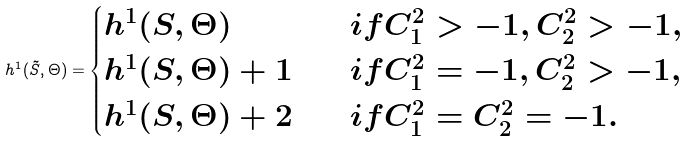<formula> <loc_0><loc_0><loc_500><loc_500>h ^ { 1 } ( \tilde { S } , \Theta ) = \begin{cases} h ^ { 1 } ( S , \Theta ) & \quad i f C _ { 1 } ^ { 2 } > - 1 , C _ { 2 } ^ { 2 } > - 1 , \\ h ^ { 1 } ( S , \Theta ) + 1 & \quad i f C _ { 1 } ^ { 2 } = - 1 , C _ { 2 } ^ { 2 } > - 1 , \\ h ^ { 1 } ( S , \Theta ) + 2 & \quad i f C _ { 1 } ^ { 2 } = C _ { 2 } ^ { 2 } = - 1 . \end{cases}</formula> 